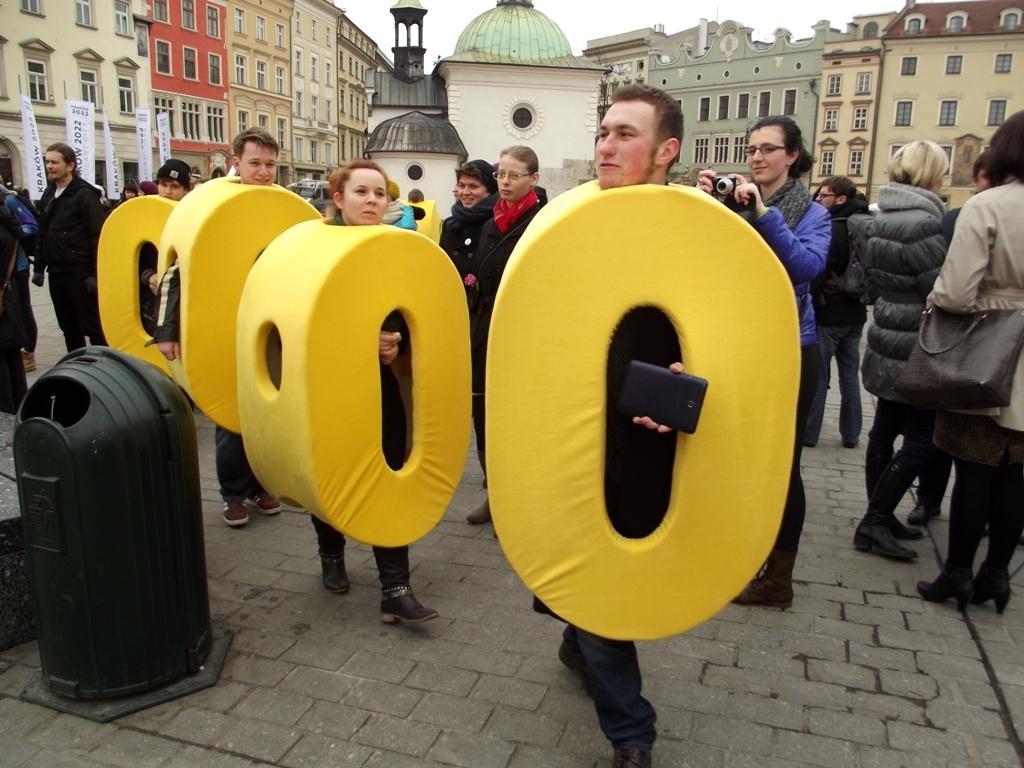Could you give a brief overview of what you see in this image? In this picture we can see there are groups of people standing and some people in the fancy dress and a person is holding a camera. Behind the people there are buildings and a sky. 